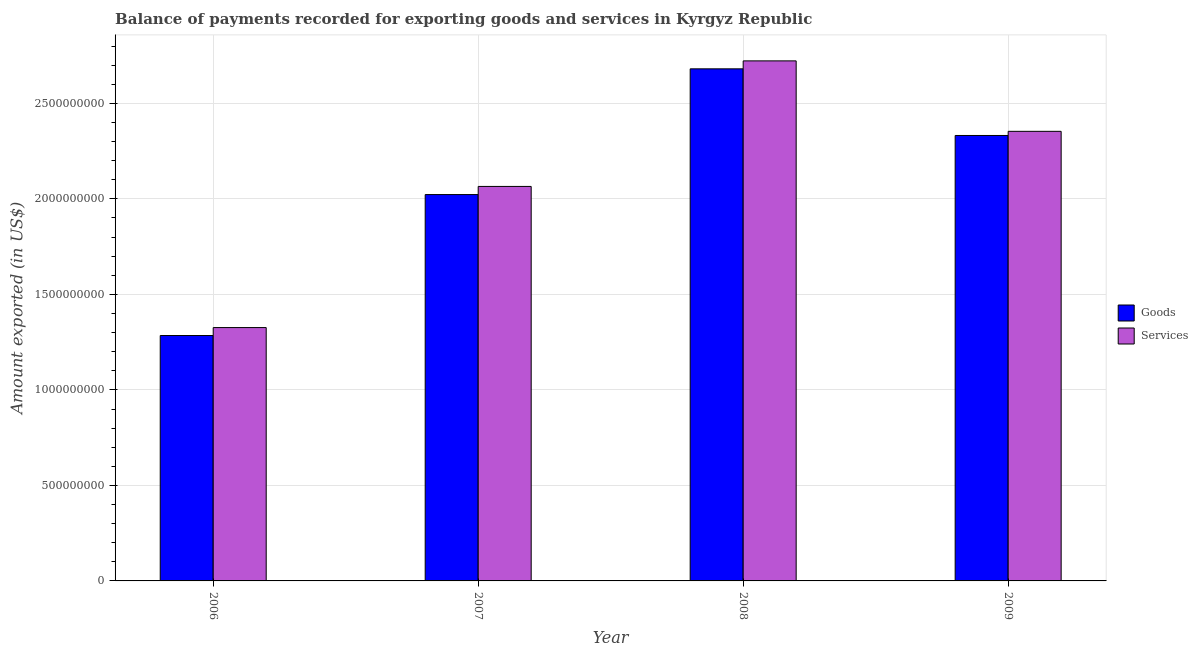How many groups of bars are there?
Ensure brevity in your answer.  4. Are the number of bars per tick equal to the number of legend labels?
Keep it short and to the point. Yes. How many bars are there on the 3rd tick from the left?
Provide a succinct answer. 2. How many bars are there on the 2nd tick from the right?
Offer a terse response. 2. What is the label of the 1st group of bars from the left?
Provide a short and direct response. 2006. In how many cases, is the number of bars for a given year not equal to the number of legend labels?
Your answer should be compact. 0. What is the amount of services exported in 2006?
Your answer should be compact. 1.33e+09. Across all years, what is the maximum amount of goods exported?
Provide a short and direct response. 2.68e+09. Across all years, what is the minimum amount of goods exported?
Ensure brevity in your answer.  1.28e+09. In which year was the amount of goods exported minimum?
Ensure brevity in your answer.  2006. What is the total amount of services exported in the graph?
Provide a short and direct response. 8.47e+09. What is the difference between the amount of goods exported in 2007 and that in 2008?
Provide a succinct answer. -6.58e+08. What is the difference between the amount of goods exported in 2008 and the amount of services exported in 2007?
Give a very brief answer. 6.58e+08. What is the average amount of goods exported per year?
Your response must be concise. 2.08e+09. What is the ratio of the amount of services exported in 2006 to that in 2008?
Make the answer very short. 0.49. Is the difference between the amount of goods exported in 2008 and 2009 greater than the difference between the amount of services exported in 2008 and 2009?
Provide a succinct answer. No. What is the difference between the highest and the second highest amount of goods exported?
Ensure brevity in your answer.  3.49e+08. What is the difference between the highest and the lowest amount of goods exported?
Your response must be concise. 1.40e+09. What does the 1st bar from the left in 2006 represents?
Your answer should be compact. Goods. What does the 1st bar from the right in 2006 represents?
Offer a terse response. Services. Are the values on the major ticks of Y-axis written in scientific E-notation?
Offer a very short reply. No. Does the graph contain any zero values?
Provide a short and direct response. No. What is the title of the graph?
Provide a short and direct response. Balance of payments recorded for exporting goods and services in Kyrgyz Republic. Does "Enforce a contract" appear as one of the legend labels in the graph?
Your answer should be very brief. No. What is the label or title of the Y-axis?
Make the answer very short. Amount exported (in US$). What is the Amount exported (in US$) in Goods in 2006?
Keep it short and to the point. 1.28e+09. What is the Amount exported (in US$) of Services in 2006?
Offer a terse response. 1.33e+09. What is the Amount exported (in US$) of Goods in 2007?
Provide a succinct answer. 2.02e+09. What is the Amount exported (in US$) in Services in 2007?
Offer a very short reply. 2.07e+09. What is the Amount exported (in US$) in Goods in 2008?
Provide a succinct answer. 2.68e+09. What is the Amount exported (in US$) in Services in 2008?
Offer a terse response. 2.72e+09. What is the Amount exported (in US$) of Goods in 2009?
Provide a short and direct response. 2.33e+09. What is the Amount exported (in US$) of Services in 2009?
Give a very brief answer. 2.35e+09. Across all years, what is the maximum Amount exported (in US$) in Goods?
Keep it short and to the point. 2.68e+09. Across all years, what is the maximum Amount exported (in US$) in Services?
Make the answer very short. 2.72e+09. Across all years, what is the minimum Amount exported (in US$) in Goods?
Offer a very short reply. 1.28e+09. Across all years, what is the minimum Amount exported (in US$) in Services?
Give a very brief answer. 1.33e+09. What is the total Amount exported (in US$) of Goods in the graph?
Your answer should be compact. 8.32e+09. What is the total Amount exported (in US$) in Services in the graph?
Provide a succinct answer. 8.47e+09. What is the difference between the Amount exported (in US$) of Goods in 2006 and that in 2007?
Offer a very short reply. -7.38e+08. What is the difference between the Amount exported (in US$) in Services in 2006 and that in 2007?
Your answer should be very brief. -7.39e+08. What is the difference between the Amount exported (in US$) in Goods in 2006 and that in 2008?
Your answer should be compact. -1.40e+09. What is the difference between the Amount exported (in US$) of Services in 2006 and that in 2008?
Your answer should be very brief. -1.40e+09. What is the difference between the Amount exported (in US$) of Goods in 2006 and that in 2009?
Your answer should be very brief. -1.05e+09. What is the difference between the Amount exported (in US$) of Services in 2006 and that in 2009?
Ensure brevity in your answer.  -1.03e+09. What is the difference between the Amount exported (in US$) in Goods in 2007 and that in 2008?
Your response must be concise. -6.58e+08. What is the difference between the Amount exported (in US$) of Services in 2007 and that in 2008?
Offer a terse response. -6.57e+08. What is the difference between the Amount exported (in US$) of Goods in 2007 and that in 2009?
Provide a short and direct response. -3.09e+08. What is the difference between the Amount exported (in US$) in Services in 2007 and that in 2009?
Give a very brief answer. -2.88e+08. What is the difference between the Amount exported (in US$) of Goods in 2008 and that in 2009?
Your response must be concise. 3.49e+08. What is the difference between the Amount exported (in US$) of Services in 2008 and that in 2009?
Provide a short and direct response. 3.69e+08. What is the difference between the Amount exported (in US$) in Goods in 2006 and the Amount exported (in US$) in Services in 2007?
Give a very brief answer. -7.81e+08. What is the difference between the Amount exported (in US$) in Goods in 2006 and the Amount exported (in US$) in Services in 2008?
Offer a very short reply. -1.44e+09. What is the difference between the Amount exported (in US$) of Goods in 2006 and the Amount exported (in US$) of Services in 2009?
Your response must be concise. -1.07e+09. What is the difference between the Amount exported (in US$) of Goods in 2007 and the Amount exported (in US$) of Services in 2008?
Offer a very short reply. -7.00e+08. What is the difference between the Amount exported (in US$) of Goods in 2007 and the Amount exported (in US$) of Services in 2009?
Give a very brief answer. -3.31e+08. What is the difference between the Amount exported (in US$) in Goods in 2008 and the Amount exported (in US$) in Services in 2009?
Offer a terse response. 3.27e+08. What is the average Amount exported (in US$) in Goods per year?
Offer a very short reply. 2.08e+09. What is the average Amount exported (in US$) in Services per year?
Offer a terse response. 2.12e+09. In the year 2006, what is the difference between the Amount exported (in US$) in Goods and Amount exported (in US$) in Services?
Offer a very short reply. -4.16e+07. In the year 2007, what is the difference between the Amount exported (in US$) of Goods and Amount exported (in US$) of Services?
Make the answer very short. -4.26e+07. In the year 2008, what is the difference between the Amount exported (in US$) in Goods and Amount exported (in US$) in Services?
Your answer should be compact. -4.17e+07. In the year 2009, what is the difference between the Amount exported (in US$) in Goods and Amount exported (in US$) in Services?
Give a very brief answer. -2.17e+07. What is the ratio of the Amount exported (in US$) of Goods in 2006 to that in 2007?
Keep it short and to the point. 0.64. What is the ratio of the Amount exported (in US$) of Services in 2006 to that in 2007?
Offer a very short reply. 0.64. What is the ratio of the Amount exported (in US$) of Goods in 2006 to that in 2008?
Your response must be concise. 0.48. What is the ratio of the Amount exported (in US$) of Services in 2006 to that in 2008?
Keep it short and to the point. 0.49. What is the ratio of the Amount exported (in US$) of Goods in 2006 to that in 2009?
Provide a succinct answer. 0.55. What is the ratio of the Amount exported (in US$) of Services in 2006 to that in 2009?
Give a very brief answer. 0.56. What is the ratio of the Amount exported (in US$) of Goods in 2007 to that in 2008?
Provide a short and direct response. 0.75. What is the ratio of the Amount exported (in US$) of Services in 2007 to that in 2008?
Your answer should be compact. 0.76. What is the ratio of the Amount exported (in US$) of Goods in 2007 to that in 2009?
Make the answer very short. 0.87. What is the ratio of the Amount exported (in US$) of Services in 2007 to that in 2009?
Offer a very short reply. 0.88. What is the ratio of the Amount exported (in US$) of Goods in 2008 to that in 2009?
Offer a terse response. 1.15. What is the ratio of the Amount exported (in US$) of Services in 2008 to that in 2009?
Your answer should be very brief. 1.16. What is the difference between the highest and the second highest Amount exported (in US$) of Goods?
Offer a terse response. 3.49e+08. What is the difference between the highest and the second highest Amount exported (in US$) of Services?
Keep it short and to the point. 3.69e+08. What is the difference between the highest and the lowest Amount exported (in US$) of Goods?
Keep it short and to the point. 1.40e+09. What is the difference between the highest and the lowest Amount exported (in US$) in Services?
Provide a short and direct response. 1.40e+09. 